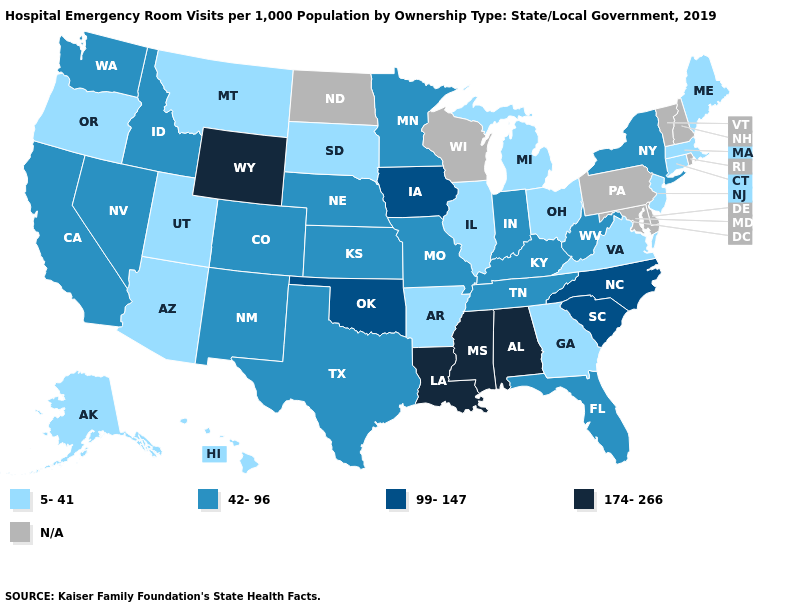Does Florida have the lowest value in the USA?
Write a very short answer. No. Which states hav the highest value in the Northeast?
Quick response, please. New York. Which states have the highest value in the USA?
Write a very short answer. Alabama, Louisiana, Mississippi, Wyoming. Does Minnesota have the highest value in the MidWest?
Be succinct. No. Among the states that border Washington , which have the lowest value?
Quick response, please. Oregon. Name the states that have a value in the range 174-266?
Keep it brief. Alabama, Louisiana, Mississippi, Wyoming. Name the states that have a value in the range 5-41?
Keep it brief. Alaska, Arizona, Arkansas, Connecticut, Georgia, Hawaii, Illinois, Maine, Massachusetts, Michigan, Montana, New Jersey, Ohio, Oregon, South Dakota, Utah, Virginia. Name the states that have a value in the range N/A?
Quick response, please. Delaware, Maryland, New Hampshire, North Dakota, Pennsylvania, Rhode Island, Vermont, Wisconsin. Is the legend a continuous bar?
Short answer required. No. Among the states that border North Dakota , which have the lowest value?
Give a very brief answer. Montana, South Dakota. Name the states that have a value in the range 5-41?
Quick response, please. Alaska, Arizona, Arkansas, Connecticut, Georgia, Hawaii, Illinois, Maine, Massachusetts, Michigan, Montana, New Jersey, Ohio, Oregon, South Dakota, Utah, Virginia. What is the value of Illinois?
Short answer required. 5-41. Name the states that have a value in the range 174-266?
Write a very short answer. Alabama, Louisiana, Mississippi, Wyoming. How many symbols are there in the legend?
Answer briefly. 5. Does New Jersey have the lowest value in the Northeast?
Be succinct. Yes. 